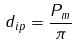Convert formula to latex. <formula><loc_0><loc_0><loc_500><loc_500>d _ { i p } = \frac { P _ { m } } { \pi }</formula> 